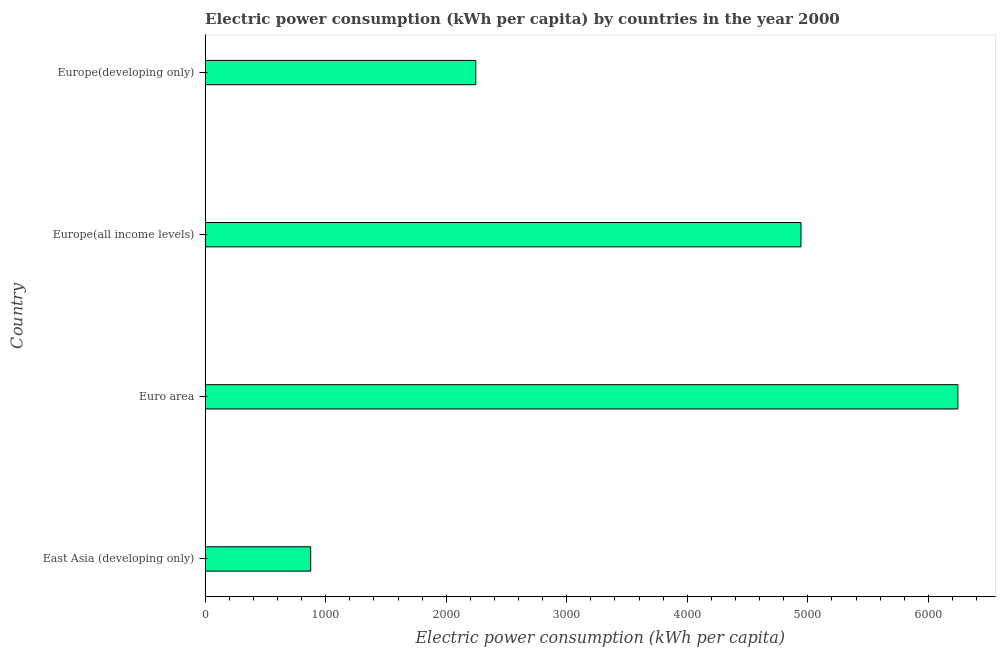Does the graph contain grids?
Your answer should be compact. No. What is the title of the graph?
Ensure brevity in your answer.  Electric power consumption (kWh per capita) by countries in the year 2000. What is the label or title of the X-axis?
Ensure brevity in your answer.  Electric power consumption (kWh per capita). What is the electric power consumption in East Asia (developing only)?
Provide a short and direct response. 875.26. Across all countries, what is the maximum electric power consumption?
Your answer should be very brief. 6245.1. Across all countries, what is the minimum electric power consumption?
Make the answer very short. 875.26. In which country was the electric power consumption maximum?
Offer a very short reply. Euro area. In which country was the electric power consumption minimum?
Offer a terse response. East Asia (developing only). What is the sum of the electric power consumption?
Your response must be concise. 1.43e+04. What is the difference between the electric power consumption in Europe(all income levels) and Europe(developing only)?
Make the answer very short. 2698.19. What is the average electric power consumption per country?
Your answer should be very brief. 3577.21. What is the median electric power consumption?
Offer a terse response. 3594.25. In how many countries, is the electric power consumption greater than 4200 kWh per capita?
Make the answer very short. 2. What is the ratio of the electric power consumption in Euro area to that in Europe(developing only)?
Offer a terse response. 2.78. Is the electric power consumption in Europe(all income levels) less than that in Europe(developing only)?
Your answer should be compact. No. Is the difference between the electric power consumption in Euro area and Europe(all income levels) greater than the difference between any two countries?
Make the answer very short. No. What is the difference between the highest and the second highest electric power consumption?
Your answer should be very brief. 1301.75. Is the sum of the electric power consumption in East Asia (developing only) and Euro area greater than the maximum electric power consumption across all countries?
Offer a terse response. Yes. What is the difference between the highest and the lowest electric power consumption?
Your response must be concise. 5369.84. How many bars are there?
Your response must be concise. 4. How many countries are there in the graph?
Give a very brief answer. 4. What is the difference between two consecutive major ticks on the X-axis?
Offer a terse response. 1000. Are the values on the major ticks of X-axis written in scientific E-notation?
Offer a very short reply. No. What is the Electric power consumption (kWh per capita) of East Asia (developing only)?
Offer a terse response. 875.26. What is the Electric power consumption (kWh per capita) in Euro area?
Give a very brief answer. 6245.1. What is the Electric power consumption (kWh per capita) in Europe(all income levels)?
Make the answer very short. 4943.34. What is the Electric power consumption (kWh per capita) in Europe(developing only)?
Keep it short and to the point. 2245.15. What is the difference between the Electric power consumption (kWh per capita) in East Asia (developing only) and Euro area?
Make the answer very short. -5369.84. What is the difference between the Electric power consumption (kWh per capita) in East Asia (developing only) and Europe(all income levels)?
Ensure brevity in your answer.  -4068.09. What is the difference between the Electric power consumption (kWh per capita) in East Asia (developing only) and Europe(developing only)?
Your response must be concise. -1369.89. What is the difference between the Electric power consumption (kWh per capita) in Euro area and Europe(all income levels)?
Your answer should be very brief. 1301.75. What is the difference between the Electric power consumption (kWh per capita) in Euro area and Europe(developing only)?
Your answer should be very brief. 3999.95. What is the difference between the Electric power consumption (kWh per capita) in Europe(all income levels) and Europe(developing only)?
Make the answer very short. 2698.19. What is the ratio of the Electric power consumption (kWh per capita) in East Asia (developing only) to that in Euro area?
Keep it short and to the point. 0.14. What is the ratio of the Electric power consumption (kWh per capita) in East Asia (developing only) to that in Europe(all income levels)?
Your answer should be very brief. 0.18. What is the ratio of the Electric power consumption (kWh per capita) in East Asia (developing only) to that in Europe(developing only)?
Your answer should be compact. 0.39. What is the ratio of the Electric power consumption (kWh per capita) in Euro area to that in Europe(all income levels)?
Keep it short and to the point. 1.26. What is the ratio of the Electric power consumption (kWh per capita) in Euro area to that in Europe(developing only)?
Offer a very short reply. 2.78. What is the ratio of the Electric power consumption (kWh per capita) in Europe(all income levels) to that in Europe(developing only)?
Make the answer very short. 2.2. 